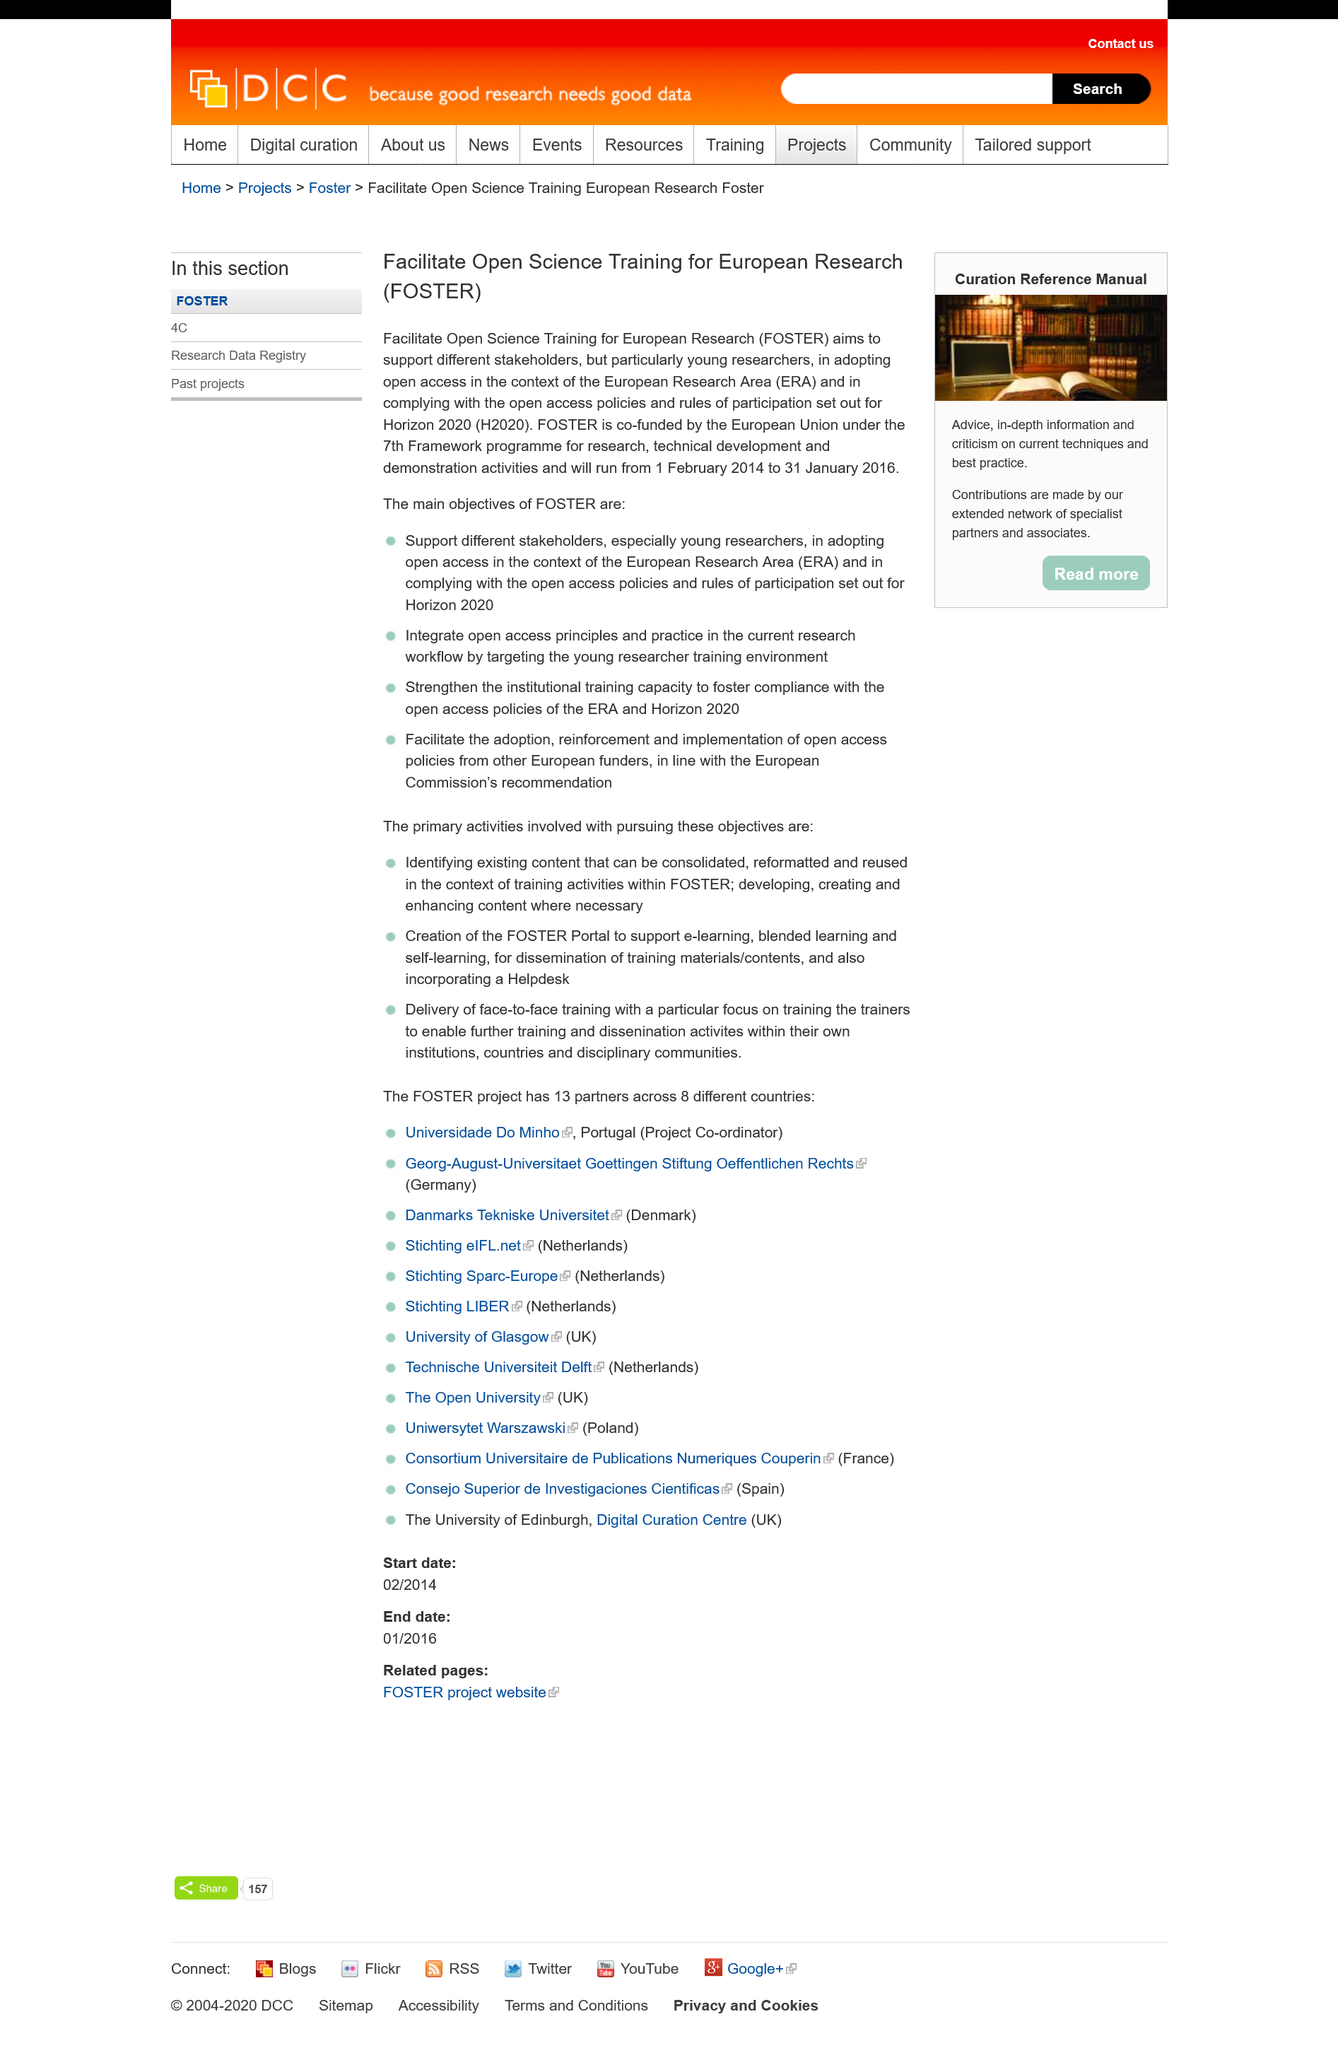Point out several critical features in this image. The project titled FOSTER will commence on 1 February 2014 and will conclude on 31 January 2016. FOSTER aims to support a wide range of stakeholders, including young researchers, who are the primary focus of their support. The objective of FOSTER is to encourage stakeholders to adopt and comply with the open access policies and rules of participation set forth for the Horizon 2020 programme, in support of the larger European Research Area (ERA) goal of promoting open access to research results and data. 